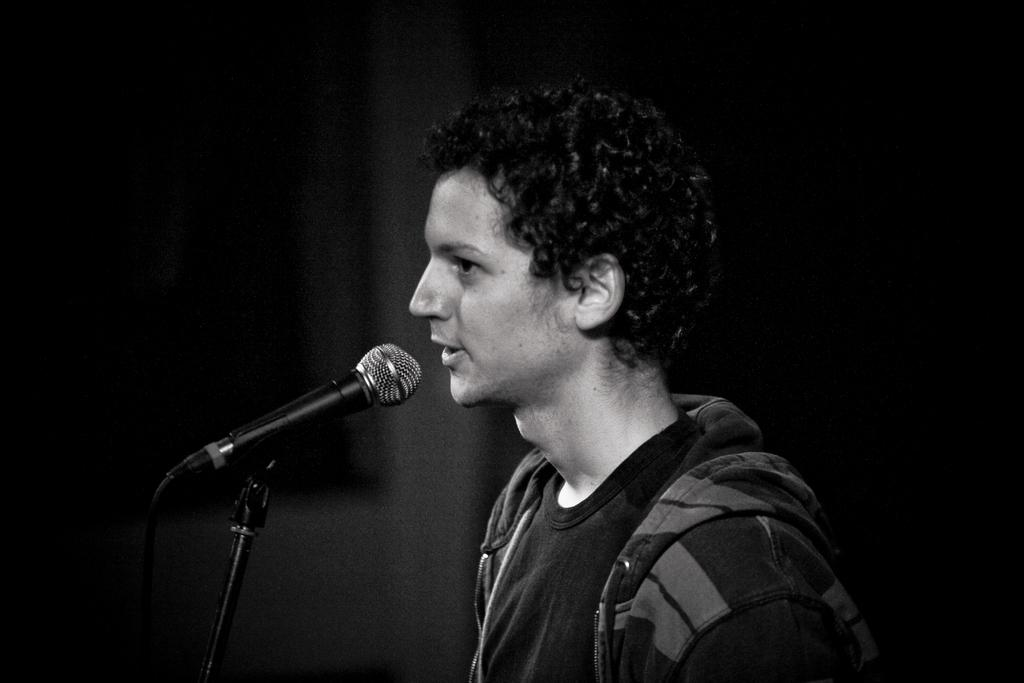Who is present in the image? There is a man in the image. What object is the man holding in the image? The man is holding a microphone (mic) in the image. What is connected to the microphone in the image? There is a cable in the image that is connected to the microphone. What is the microphone attached to in the image? There is a mic stand in the image that the microphone is attached to. What type of lettuce is being used to brush the man's hair in the image? There is no lettuce or hair brushing activity present in the image. 